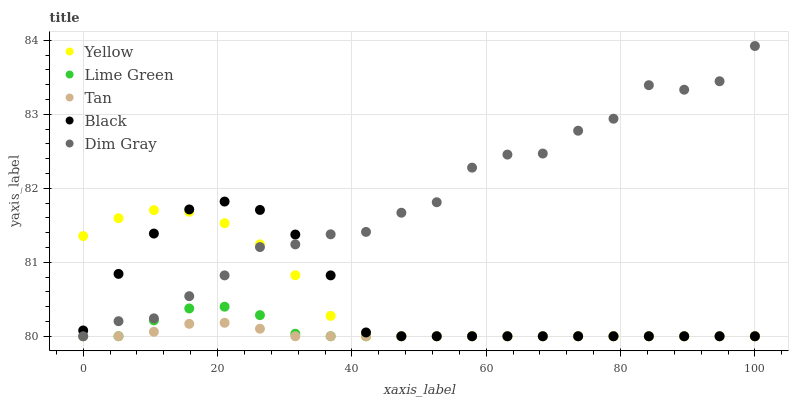Does Tan have the minimum area under the curve?
Answer yes or no. Yes. Does Dim Gray have the maximum area under the curve?
Answer yes or no. Yes. Does Dim Gray have the minimum area under the curve?
Answer yes or no. No. Does Tan have the maximum area under the curve?
Answer yes or no. No. Is Tan the smoothest?
Answer yes or no. Yes. Is Dim Gray the roughest?
Answer yes or no. Yes. Is Dim Gray the smoothest?
Answer yes or no. No. Is Tan the roughest?
Answer yes or no. No. Does Black have the lowest value?
Answer yes or no. Yes. Does Dim Gray have the highest value?
Answer yes or no. Yes. Does Tan have the highest value?
Answer yes or no. No. Does Black intersect Tan?
Answer yes or no. Yes. Is Black less than Tan?
Answer yes or no. No. Is Black greater than Tan?
Answer yes or no. No. 